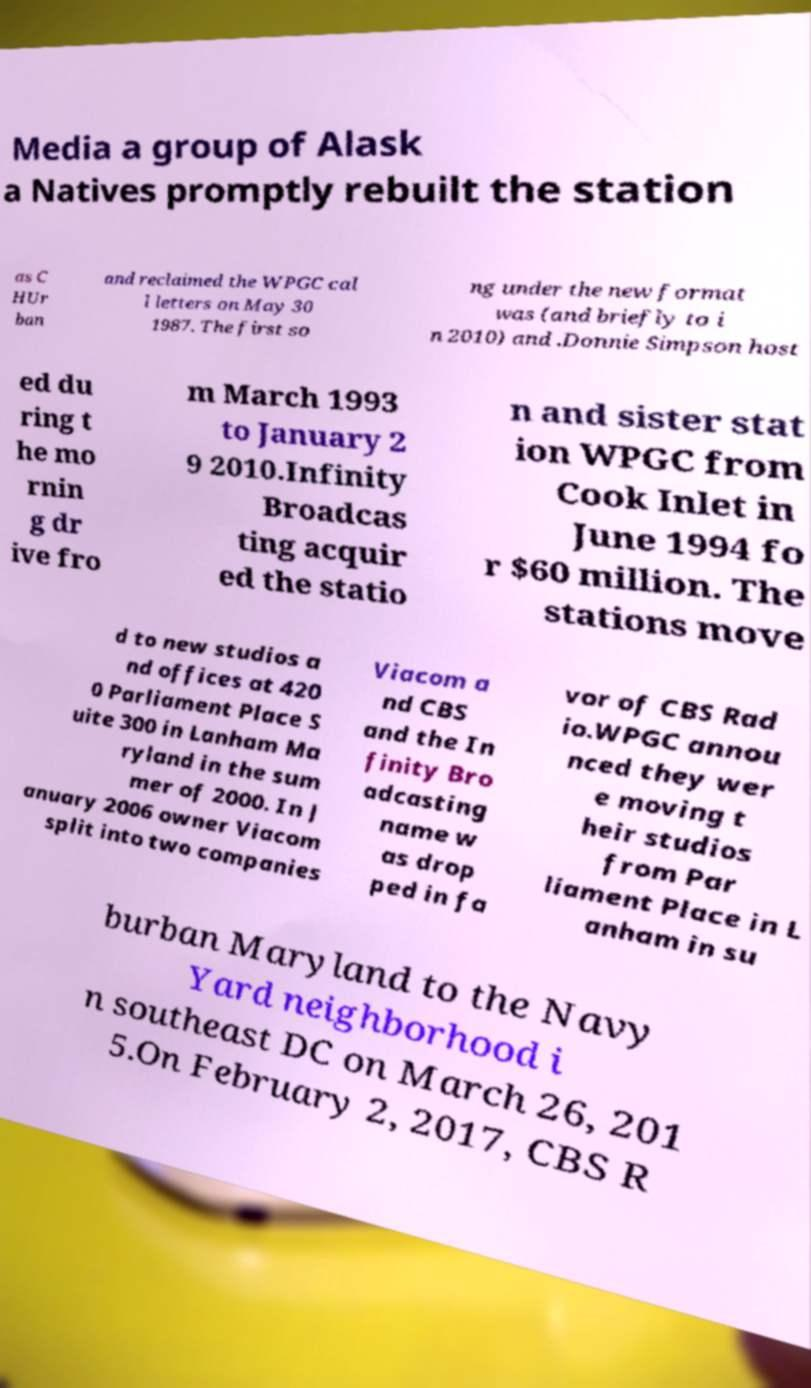Can you read and provide the text displayed in the image?This photo seems to have some interesting text. Can you extract and type it out for me? Media a group of Alask a Natives promptly rebuilt the station as C HUr ban and reclaimed the WPGC cal l letters on May 30 1987. The first so ng under the new format was (and briefly to i n 2010) and .Donnie Simpson host ed du ring t he mo rnin g dr ive fro m March 1993 to January 2 9 2010.Infinity Broadcas ting acquir ed the statio n and sister stat ion WPGC from Cook Inlet in June 1994 fo r $60 million. The stations move d to new studios a nd offices at 420 0 Parliament Place S uite 300 in Lanham Ma ryland in the sum mer of 2000. In J anuary 2006 owner Viacom split into two companies Viacom a nd CBS and the In finity Bro adcasting name w as drop ped in fa vor of CBS Rad io.WPGC annou nced they wer e moving t heir studios from Par liament Place in L anham in su burban Maryland to the Navy Yard neighborhood i n southeast DC on March 26, 201 5.On February 2, 2017, CBS R 